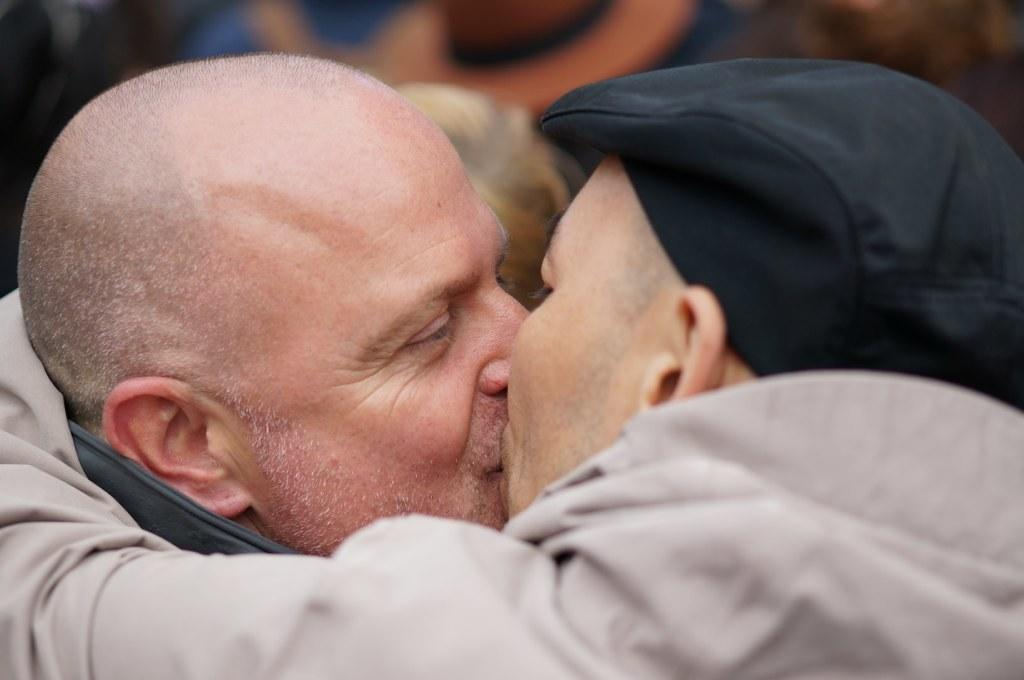What is the visual effect on the background of the image? The background portion of the picture is blurred. What activity are the men in the image engaged in? There are men kissing each other in the image. What type of soup is being served in the image? There is no soup present in the image. What year is depicted in the image? The image does not depict a specific year; it is a still photograph. 